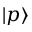Convert formula to latex. <formula><loc_0><loc_0><loc_500><loc_500>| p \rangle</formula> 